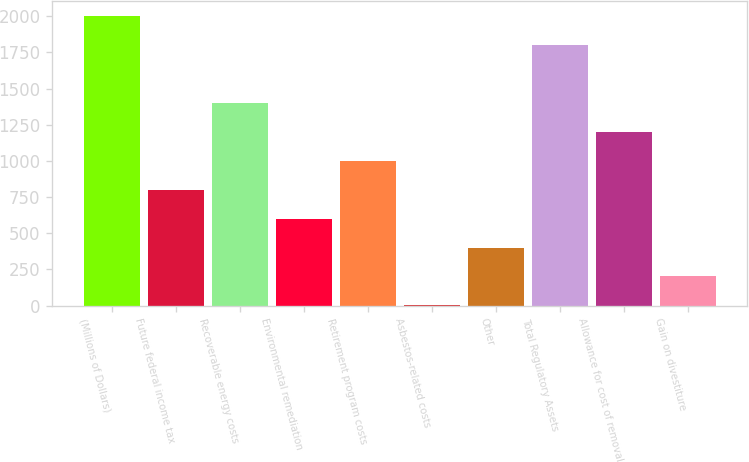Convert chart to OTSL. <chart><loc_0><loc_0><loc_500><loc_500><bar_chart><fcel>(Millions of Dollars)<fcel>Future federal income tax<fcel>Recoverable energy costs<fcel>Environmental remediation<fcel>Retirement program costs<fcel>Asbestos-related costs<fcel>Other<fcel>Total Regulatory Assets<fcel>Allowance for cost of removal<fcel>Gain on divestiture<nl><fcel>2003<fcel>801.8<fcel>1402.4<fcel>601.6<fcel>1002<fcel>1<fcel>401.4<fcel>1802.8<fcel>1202.2<fcel>201.2<nl></chart> 